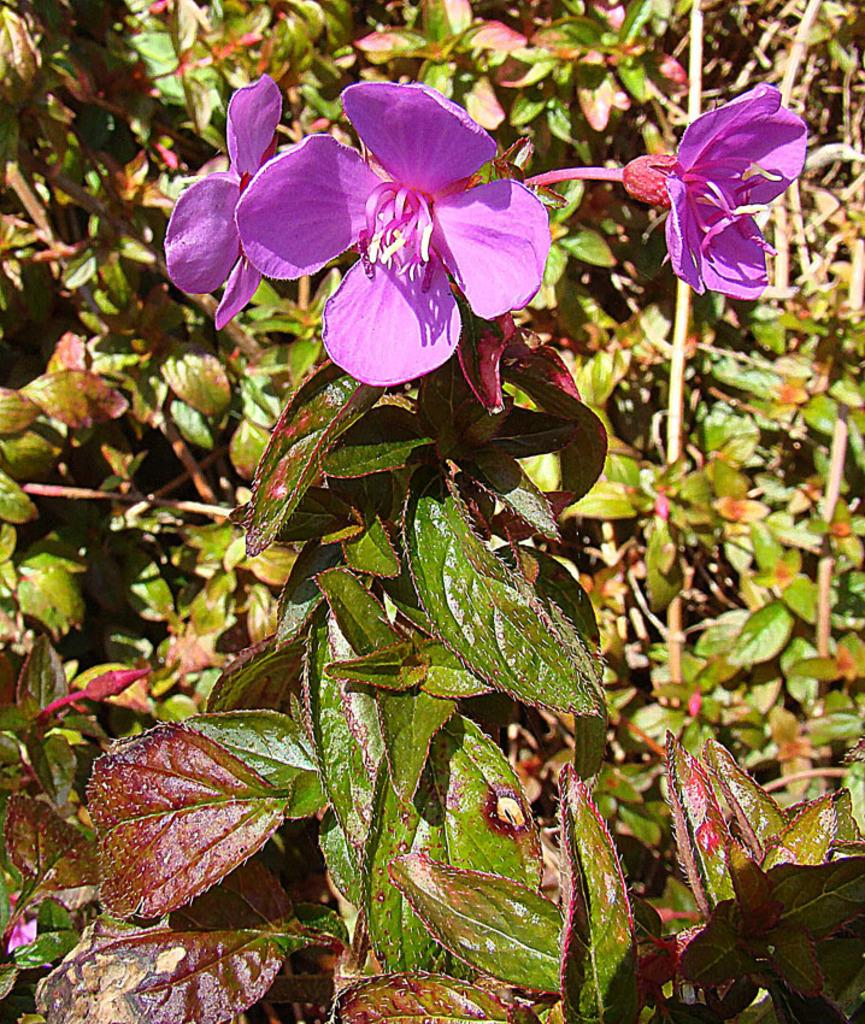What color are the flowers in the image? The flowers in the image are purple colored. What stage of growth are some of the flowers in the image? There are flower buds in the image, indicating that some flowers are in the early stages of growth. What type of vegetation is present in the image? There are plants in the image, which include the purple flowers and flower buds. What organization is responsible for the scale of the flowers in the image? There is no organization mentioned in the image, and the scale of the flowers is not relevant to the description of the image. 